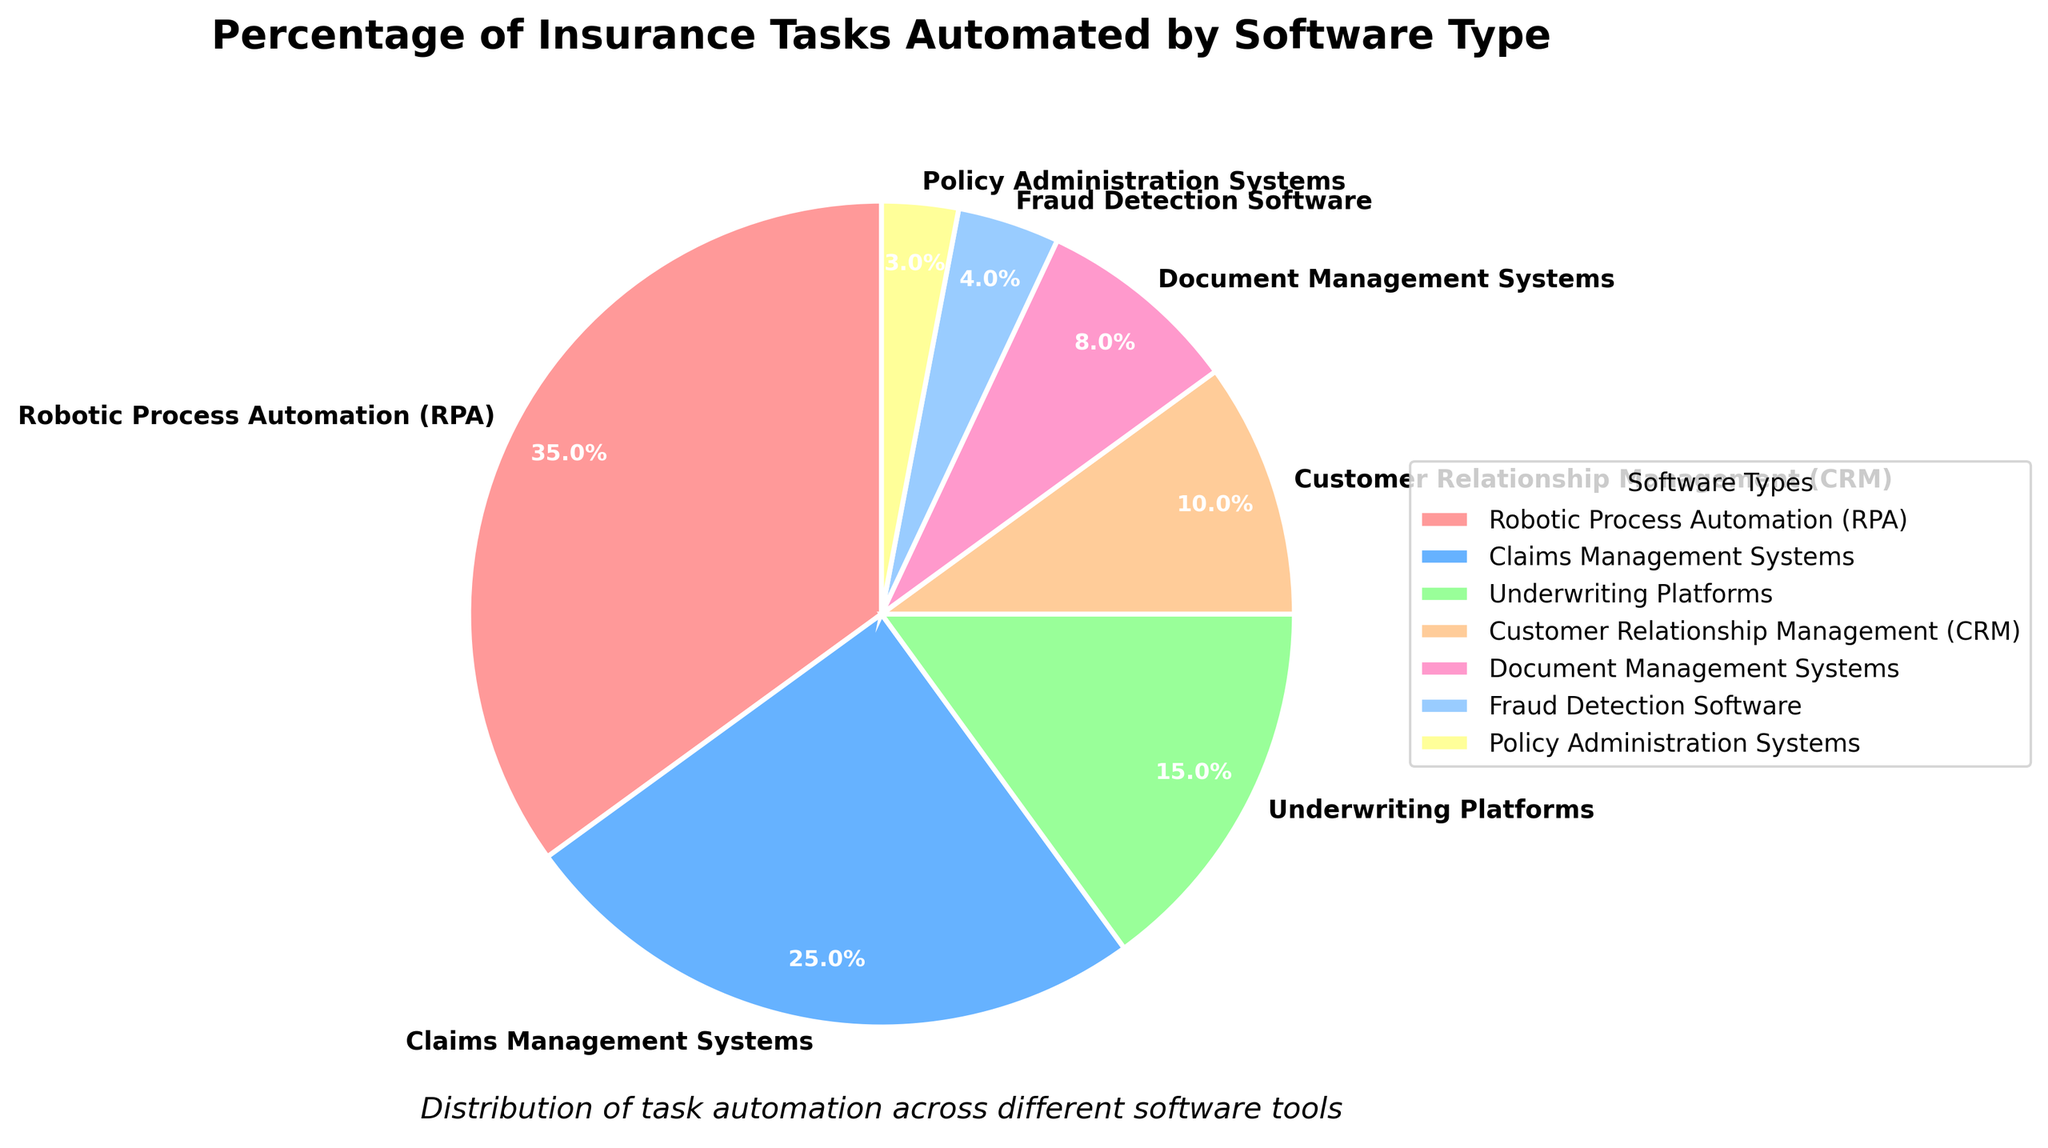How much more percentage of tasks are automated by Robotic Process Automation (RPA) compared to Underwriting Platforms? Robotic Process Automation automates 35% of tasks, while Underwriting Platforms automate 15% of tasks. The difference is 35% - 15% = 20%.
Answer: 20% Which software type automates the least percentage of tasks? Based on the pie chart, Policy Administration Systems automate the least percentage of tasks at 3%.
Answer: Policy Administration Systems What is the total percentage of tasks automated by Claims Management Systems, Customer Relationship Management (CRM), and Document Management Systems combined? Claims Management Systems automate 25%, CRM automates 10%, and Document Management Systems automate 8%. The total is 25% + 10% + 8% = 43%.
Answer: 43% Which segment in the pie chart is represented with a light blue color? By visually inspecting the pie chart, the light blue segment represents "Claims Management Systems".
Answer: Claims Management Systems Are the percentages of tasks automated by Underwriting Platforms and Fraud Detection Software combined greater or less than that of Robotic Process Automation (RPA)? Underwriting Platforms automate 15% and Fraud Detection Software automates 4%. Combined, they automate 15% + 4% = 19%, which is less than the 35% automated by RPA.
Answer: Less What is the average percentage of tasks automated by Robotic Process Automation (RPA), Claims Management Systems, and Customer Relationship Management (CRM)? Adding the percentages: 35% (RPA) + 25% (Claims Management Systems) + 10% (CRM) gives 70%. The average is 70% / 3 = 23.33%.
Answer: 23.33% How many software types automate more than 10% of tasks? By inspecting the pie chart, Robotic Process Automation (35%), Claims Management Systems (25%), and Underwriting Platforms (15%) each automate more than 10% of tasks. There are 3 such software types.
Answer: 3 Which software types together account for exactly half of the automation tasks' percentage? Robotic Process Automation automates 35% and Claims Management Systems 25%. Together, they account for 35% + 25% = 60%, which is more than half. Including Underwriting Platforms (15%) would be 35% + 25% + 15% = 75%, still more. Using Claims Management Systems and CRM (10%) gives 25% + 10% = 35%, not half. Therefore, concluding it: the closest is 2 software types that do not combine exactly to 50%.
Answer: None 